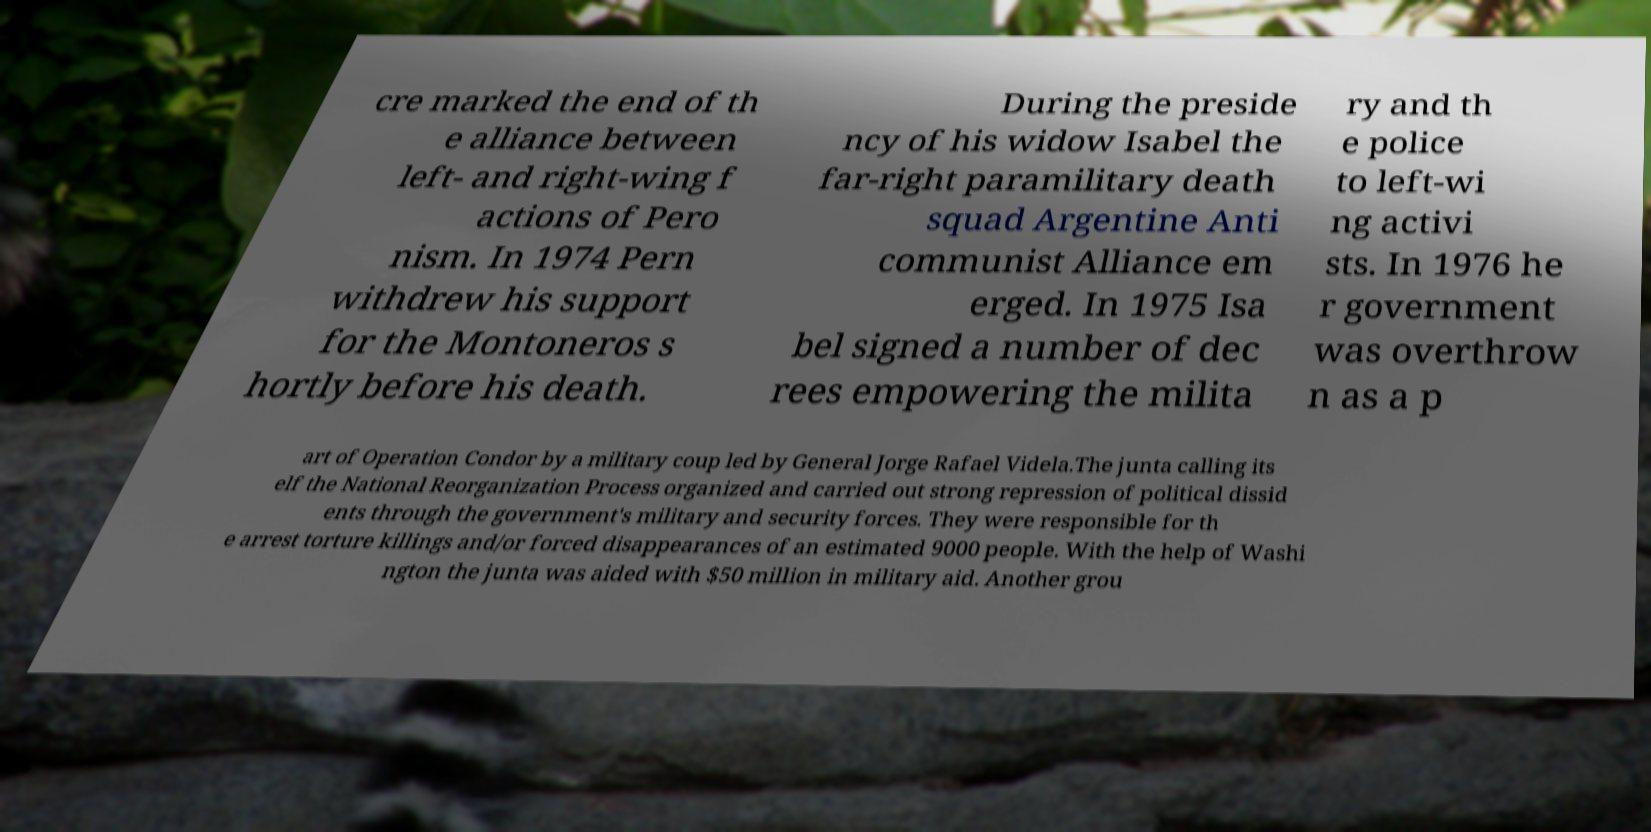For documentation purposes, I need the text within this image transcribed. Could you provide that? cre marked the end of th e alliance between left- and right-wing f actions of Pero nism. In 1974 Pern withdrew his support for the Montoneros s hortly before his death. During the preside ncy of his widow Isabel the far-right paramilitary death squad Argentine Anti communist Alliance em erged. In 1975 Isa bel signed a number of dec rees empowering the milita ry and th e police to left-wi ng activi sts. In 1976 he r government was overthrow n as a p art of Operation Condor by a military coup led by General Jorge Rafael Videla.The junta calling its elf the National Reorganization Process organized and carried out strong repression of political dissid ents through the government's military and security forces. They were responsible for th e arrest torture killings and/or forced disappearances of an estimated 9000 people. With the help of Washi ngton the junta was aided with $50 million in military aid. Another grou 